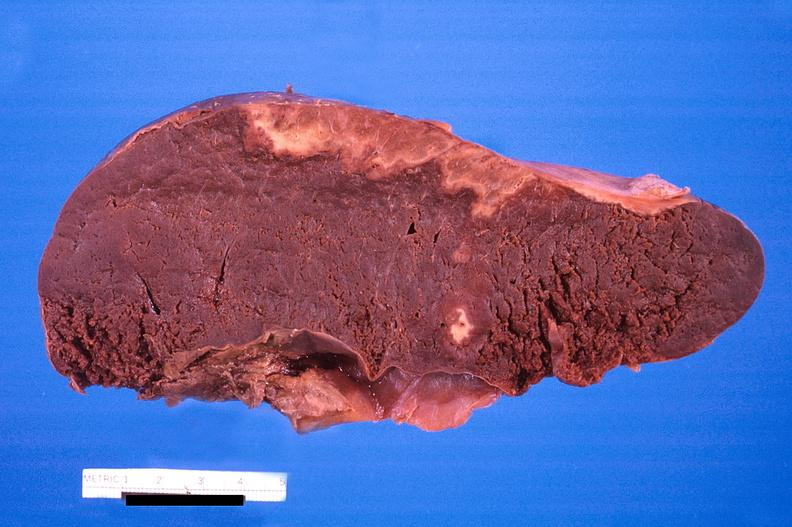what is present?
Answer the question using a single word or phrase. Hematologic 